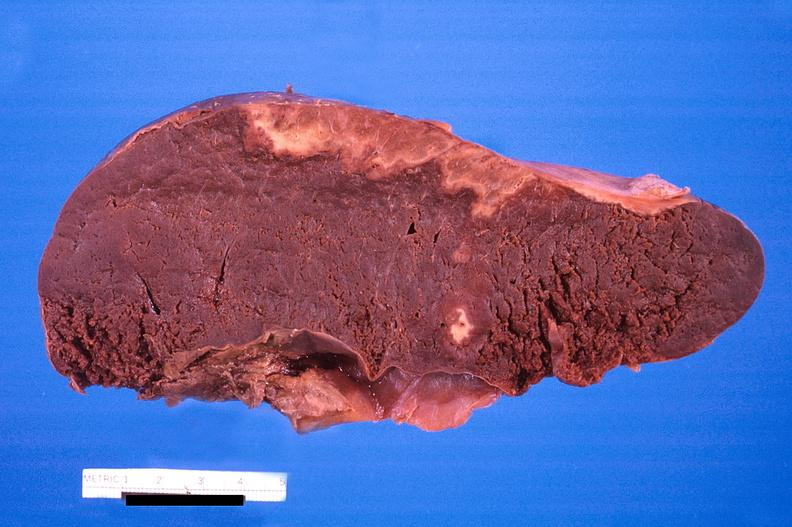what is present?
Answer the question using a single word or phrase. Hematologic 